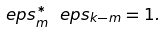<formula> <loc_0><loc_0><loc_500><loc_500>\ e p s _ { m } ^ { * } \ e p s _ { k - m } = 1 .</formula> 